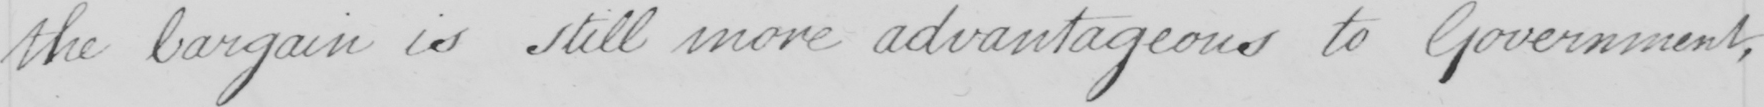Can you tell me what this handwritten text says? the bargain is still more advantageous to Government , 